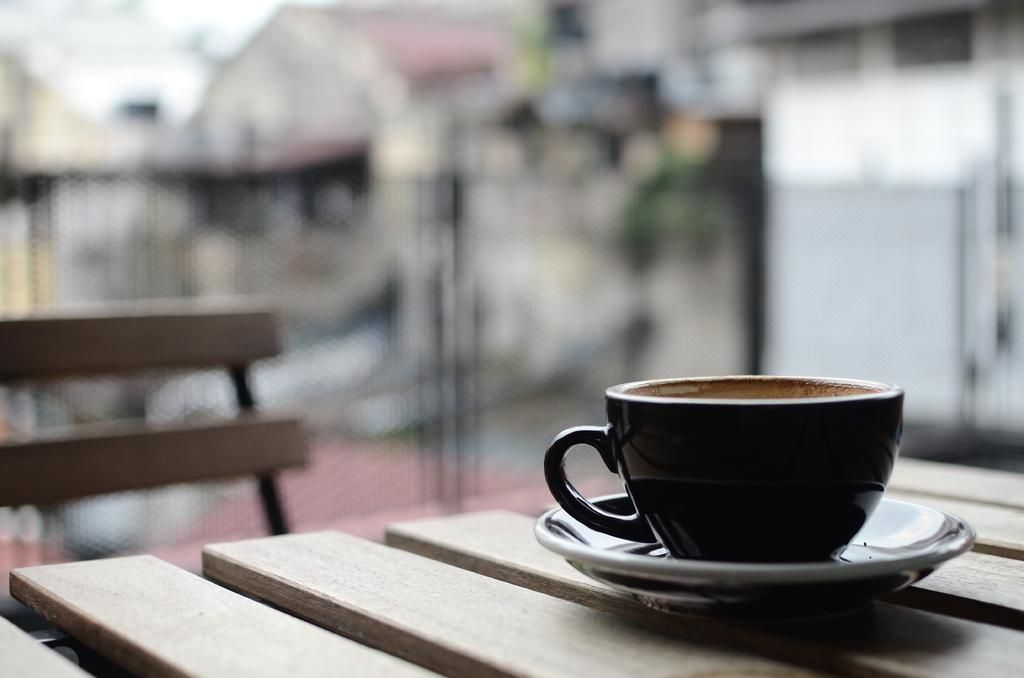What is present on the table in the image? There is a cup and a saucer on the table in the image. What is the relationship between the cup and the saucer in the image? The cup is placed on the saucer in the image. What year is depicted on the cup in the image? There is no year depicted on the cup in the image. How many mice can be seen interacting with the cup and saucer in the image? There are no mice present in the image. 